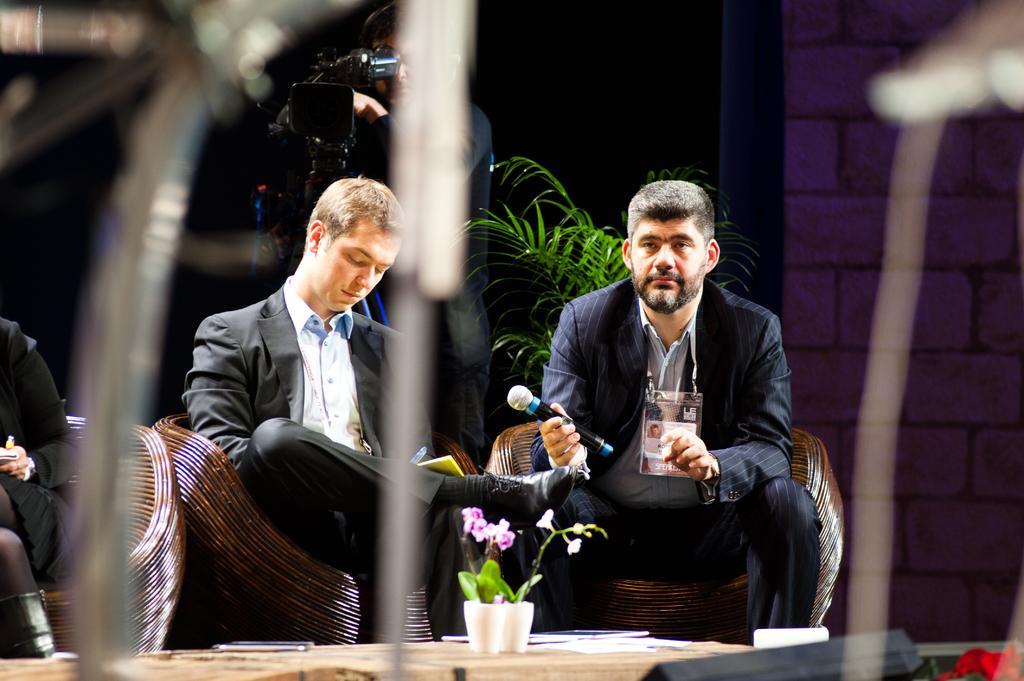Could you give a brief overview of what you see in this image? In this image there are three persons sitting on chairs, one of them is holding a mic in his hand, behind them there is a plant, beside the plant there is a person video graphing. 